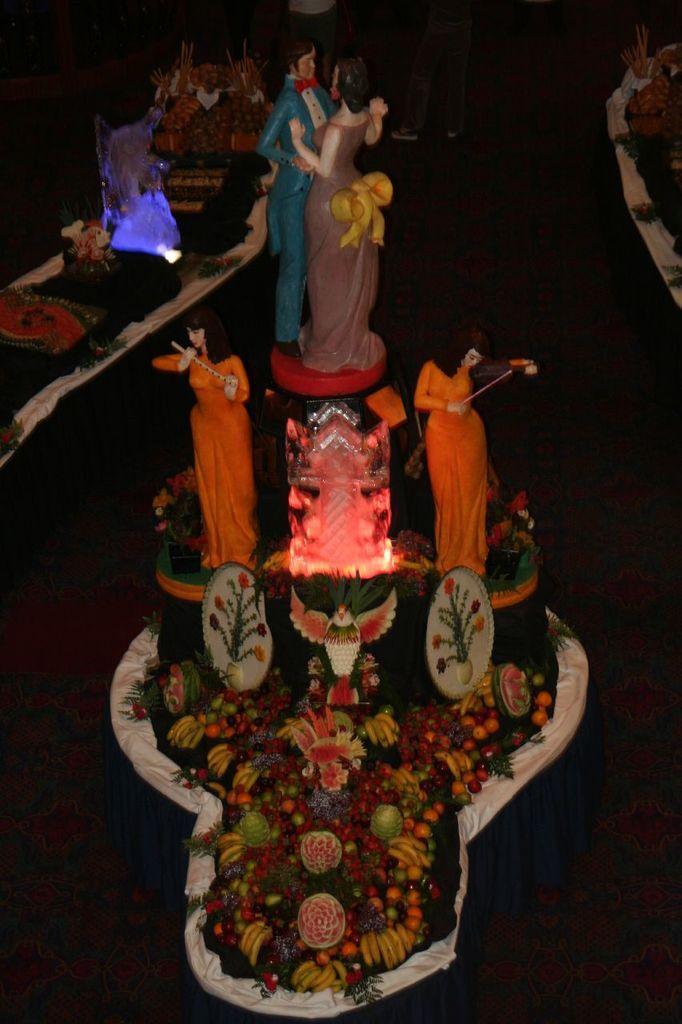How would you summarize this image in a sentence or two? In this picture we can see statues and fruits. There is a dark background. 